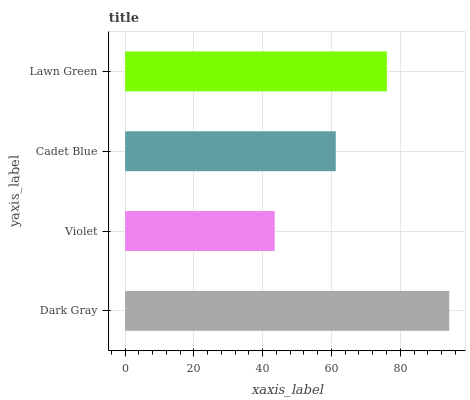Is Violet the minimum?
Answer yes or no. Yes. Is Dark Gray the maximum?
Answer yes or no. Yes. Is Cadet Blue the minimum?
Answer yes or no. No. Is Cadet Blue the maximum?
Answer yes or no. No. Is Cadet Blue greater than Violet?
Answer yes or no. Yes. Is Violet less than Cadet Blue?
Answer yes or no. Yes. Is Violet greater than Cadet Blue?
Answer yes or no. No. Is Cadet Blue less than Violet?
Answer yes or no. No. Is Lawn Green the high median?
Answer yes or no. Yes. Is Cadet Blue the low median?
Answer yes or no. Yes. Is Violet the high median?
Answer yes or no. No. Is Violet the low median?
Answer yes or no. No. 